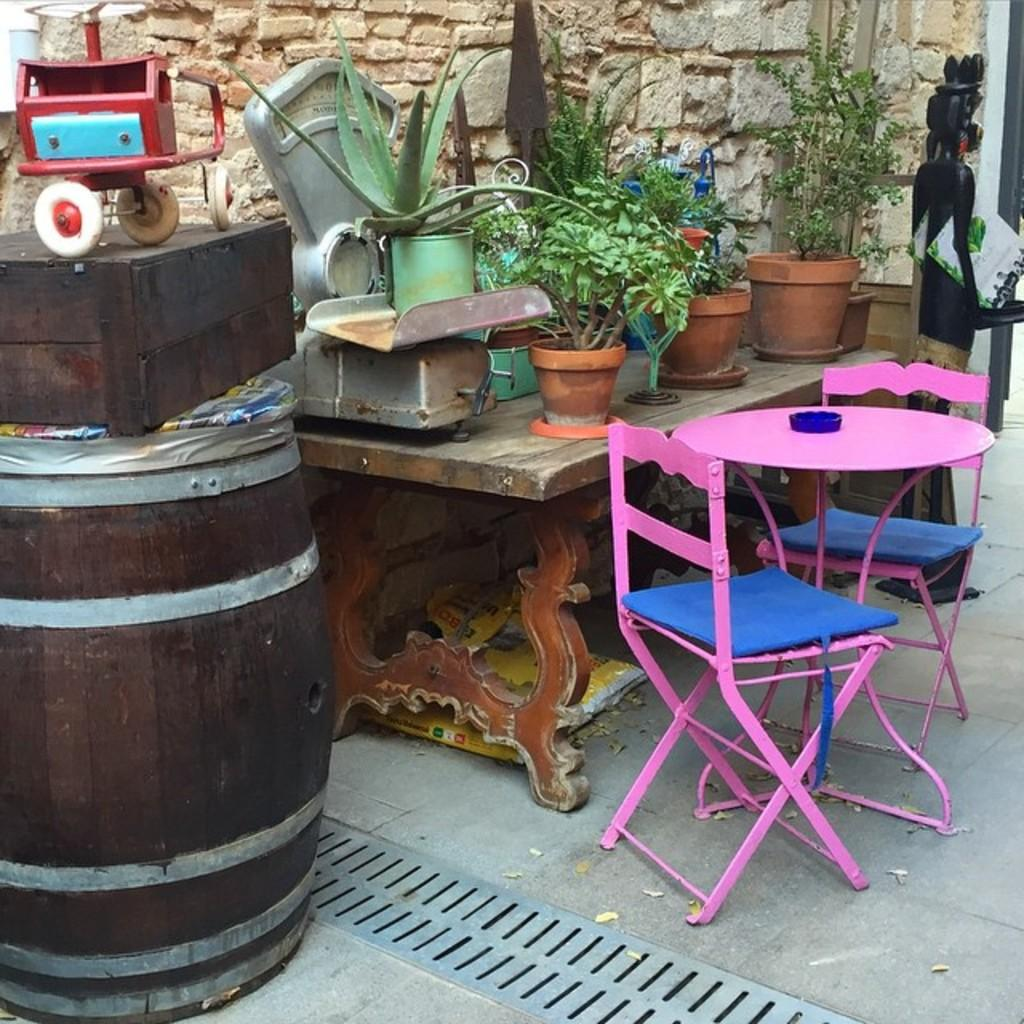What type of furniture is present in the image? There are chairs and tables in the image. What musical instrument can be seen in the image? There is a drum in the image. What is located above the drum? Above the drum, there is a box in the image. What type of object is present on the table? There is a toy on the table in the image. What kind of decorative items are on the table? On the table, there are plants in the image. Are there any other objects on the table? Yes, there are other things on the table in the image. What can be seen far from the table in the image? Far from the table, there is a sculpture in black color in the image. What type of trade is being conducted in the image? There is no indication of any trade being conducted in the image. How does the harmony between the chairs and tables contribute to the overall aesthetic of the image? The image does not specifically address the harmony between the chairs and tables, and the aesthetic of the image is not discussed in the provided facts. 